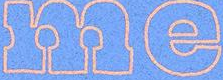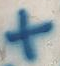What text appears in these images from left to right, separated by a semicolon? me; + 